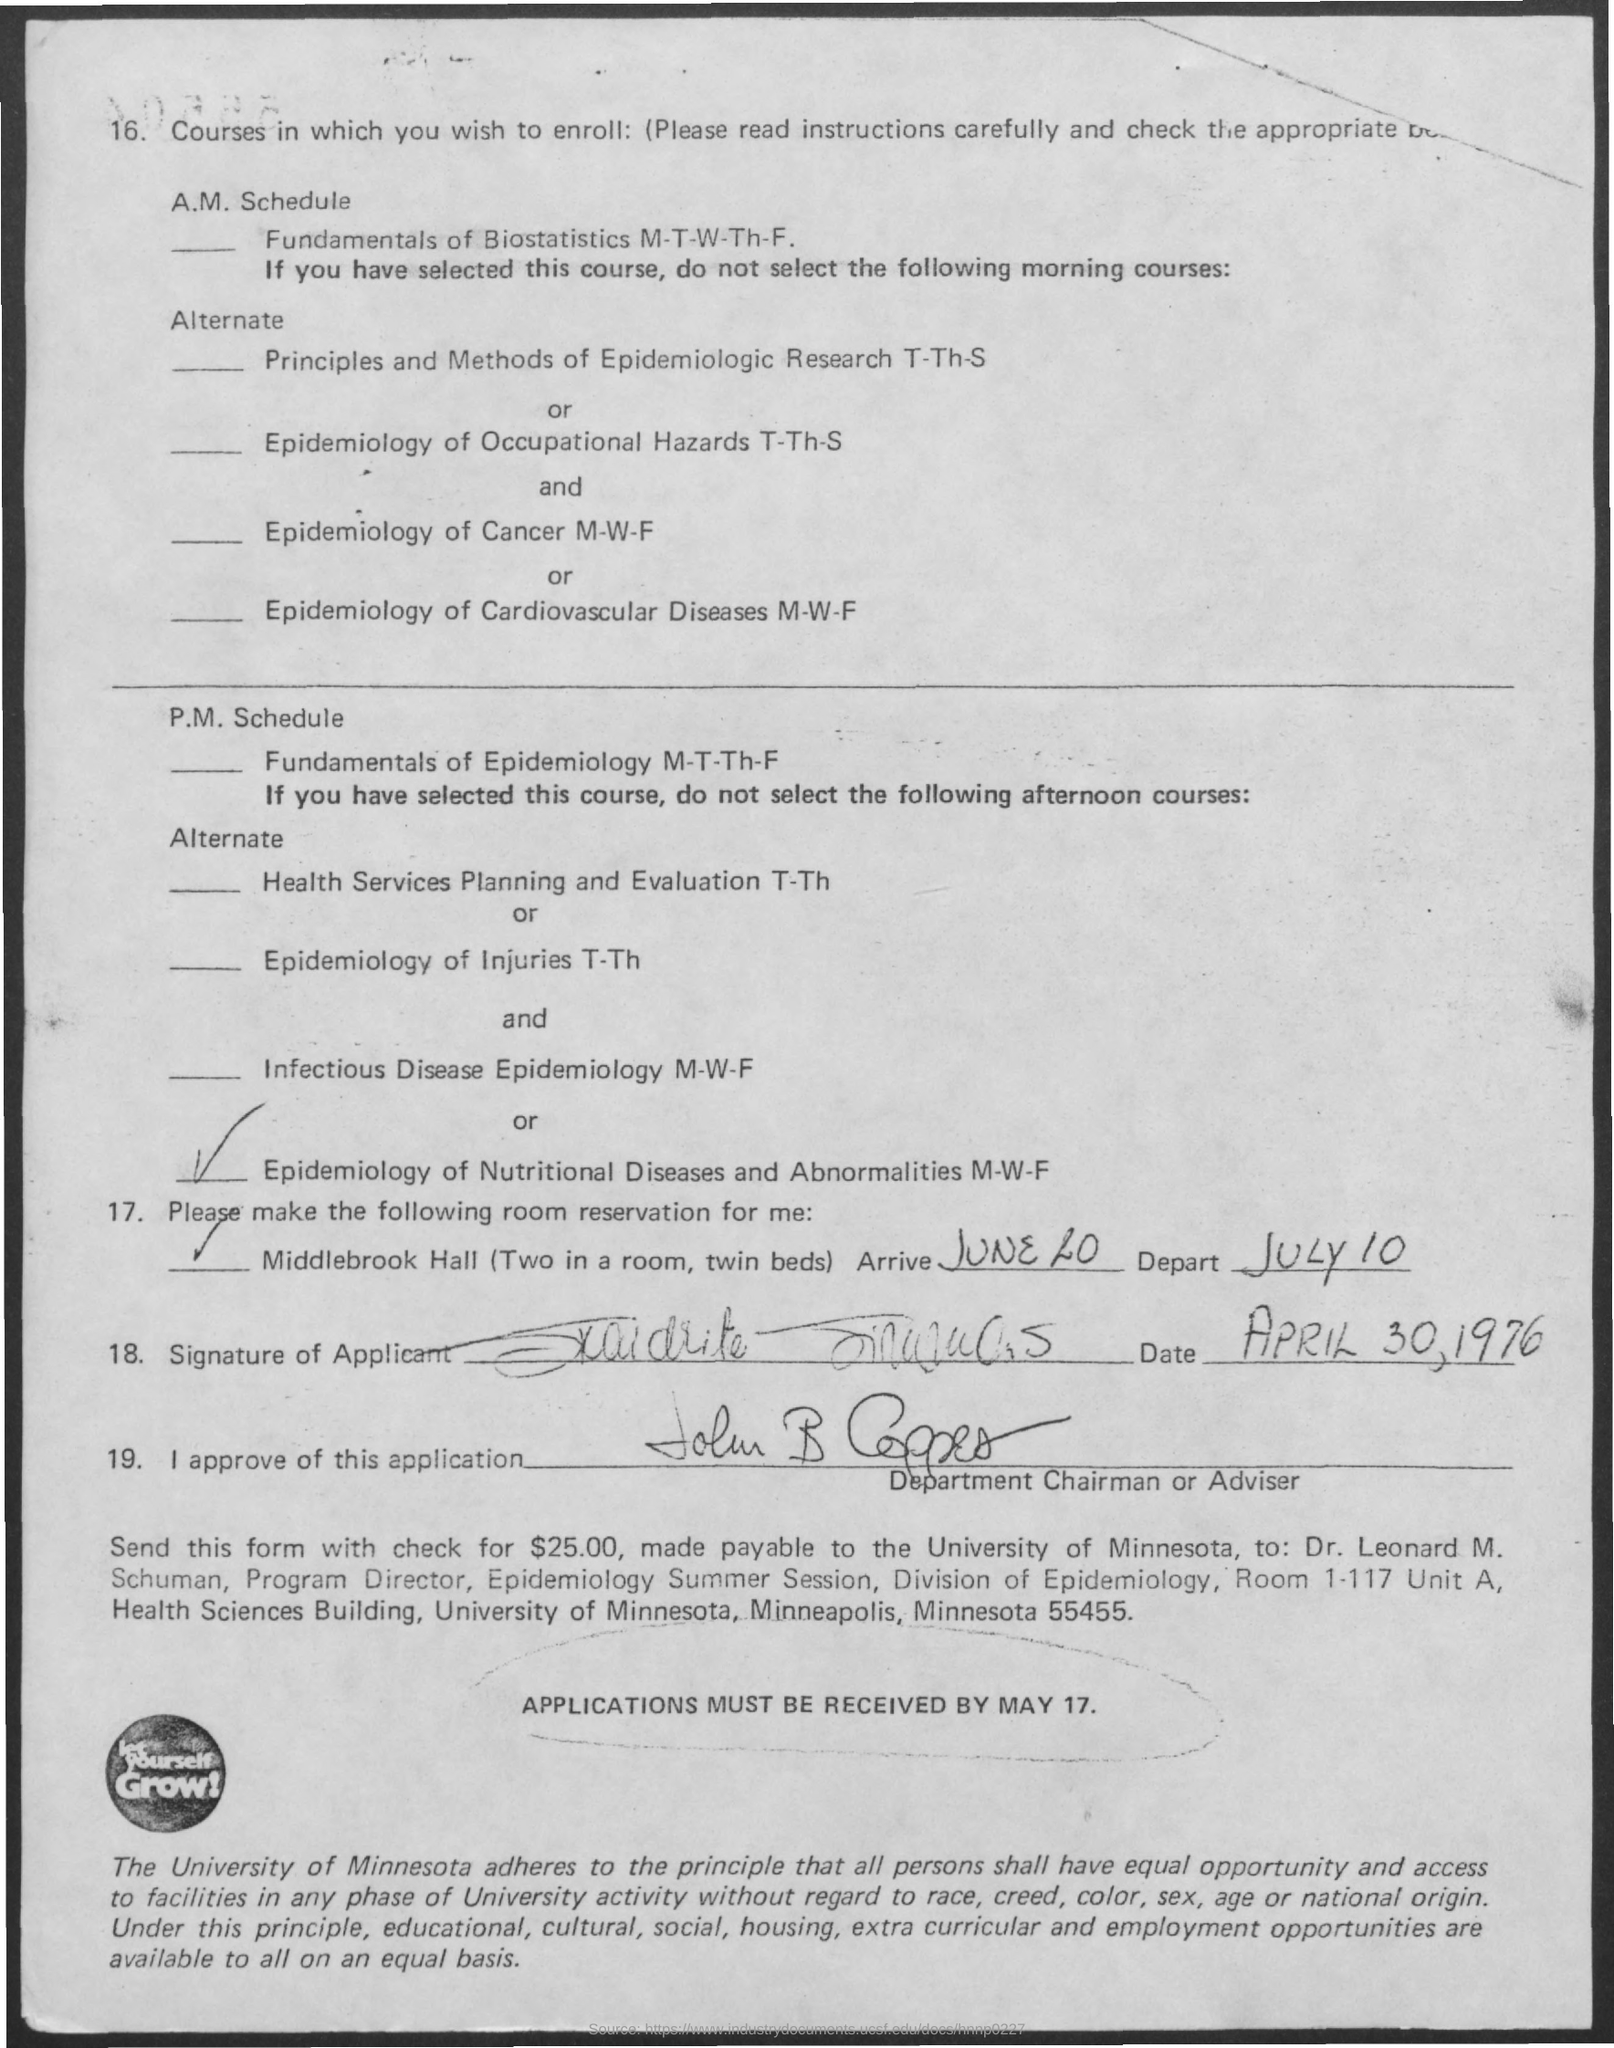Mention a couple of crucial points in this snapshot. The last date for receiving the form from the university is May 17. 